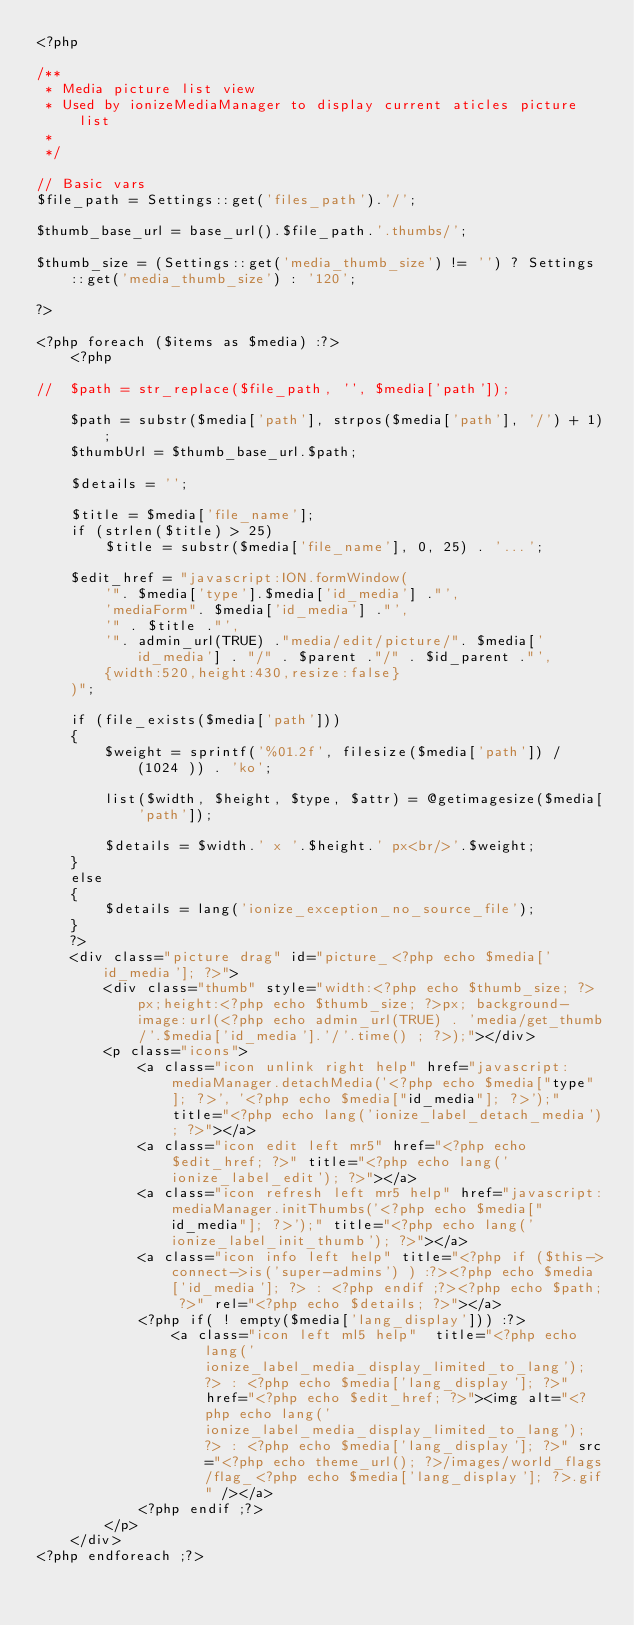Convert code to text. <code><loc_0><loc_0><loc_500><loc_500><_PHP_><?php

/** 
 * Media picture list view
 * Used by ionizeMediaManager to display current aticles picture list
 *
 */

// Basic vars
$file_path = Settings::get('files_path').'/';

$thumb_base_url = base_url().$file_path.'.thumbs/';

$thumb_size = (Settings::get('media_thumb_size') != '') ? Settings::get('media_thumb_size') : '120';

?>

<?php foreach ($items as $media) :?>
	<?php
	
//	$path = str_replace($file_path, '', $media['path']);
	
	$path = substr($media['path'], strpos($media['path'], '/') + 1);
	$thumbUrl =	$thumb_base_url.$path;

	$details = '';

	$title = $media['file_name'];
	if (strlen($title) > 25)
		$title = substr($media['file_name'], 0, 25) . '...';

	$edit_href = "javascript:ION.formWindow(
		'". $media['type'].$media['id_media'] ."',
		'mediaForm". $media['id_media'] ."',
		'" . $title ."',
		'". admin_url(TRUE) ."media/edit/picture/". $media['id_media'] . "/" . $parent ."/" . $id_parent ."',
		{width:520,height:430,resize:false}
	)";

	if (file_exists($media['path']))
	{
		$weight = sprintf('%01.2f', filesize($media['path']) / (1024 )) . 'ko';

		list($width, $height, $type, $attr) = @getimagesize($media['path']);
		
		$details = $width.' x '.$height.' px<br/>'.$weight;
	}
	else
	{
		$details = lang('ionize_exception_no_source_file');
	}
	?>
	<div class="picture drag" id="picture_<?php echo $media['id_media']; ?>">
		<div class="thumb" style="width:<?php echo $thumb_size; ?>px;height:<?php echo $thumb_size; ?>px; background-image:url(<?php echo admin_url(TRUE) . 'media/get_thumb/'.$media['id_media'].'/'.time() ; ?>);"></div>
		<p class="icons">
			<a class="icon unlink right help" href="javascript:mediaManager.detachMedia('<?php echo $media["type"]; ?>', '<?php echo $media["id_media"]; ?>');" title="<?php echo lang('ionize_label_detach_media'); ?>"></a>
			<a class="icon edit left mr5" href="<?php echo $edit_href; ?>" title="<?php echo lang('ionize_label_edit'); ?>"></a>
			<a class="icon refresh left mr5 help" href="javascript:mediaManager.initThumbs('<?php echo $media["id_media"]; ?>');" title="<?php echo lang('ionize_label_init_thumb'); ?>"></a>
			<a class="icon info left help" title="<?php if ($this->connect->is('super-admins') ) :?><?php echo $media['id_media']; ?> : <?php endif ;?><?php echo $path; ?>" rel="<?php echo $details; ?>"></a>
			<?php if( ! empty($media['lang_display'])) :?>
				<a class="icon left ml5 help"  title="<?php echo lang('ionize_label_media_display_limited_to_lang'); ?> : <?php echo $media['lang_display']; ?>" href="<?php echo $edit_href; ?>"><img alt="<?php echo lang('ionize_label_media_display_limited_to_lang'); ?> : <?php echo $media['lang_display']; ?>" src="<?php echo theme_url(); ?>/images/world_flags/flag_<?php echo $media['lang_display']; ?>.gif" /></a>
			<?php endif ;?>
		</p>
	</div>
<?php endforeach ;?>

</code> 